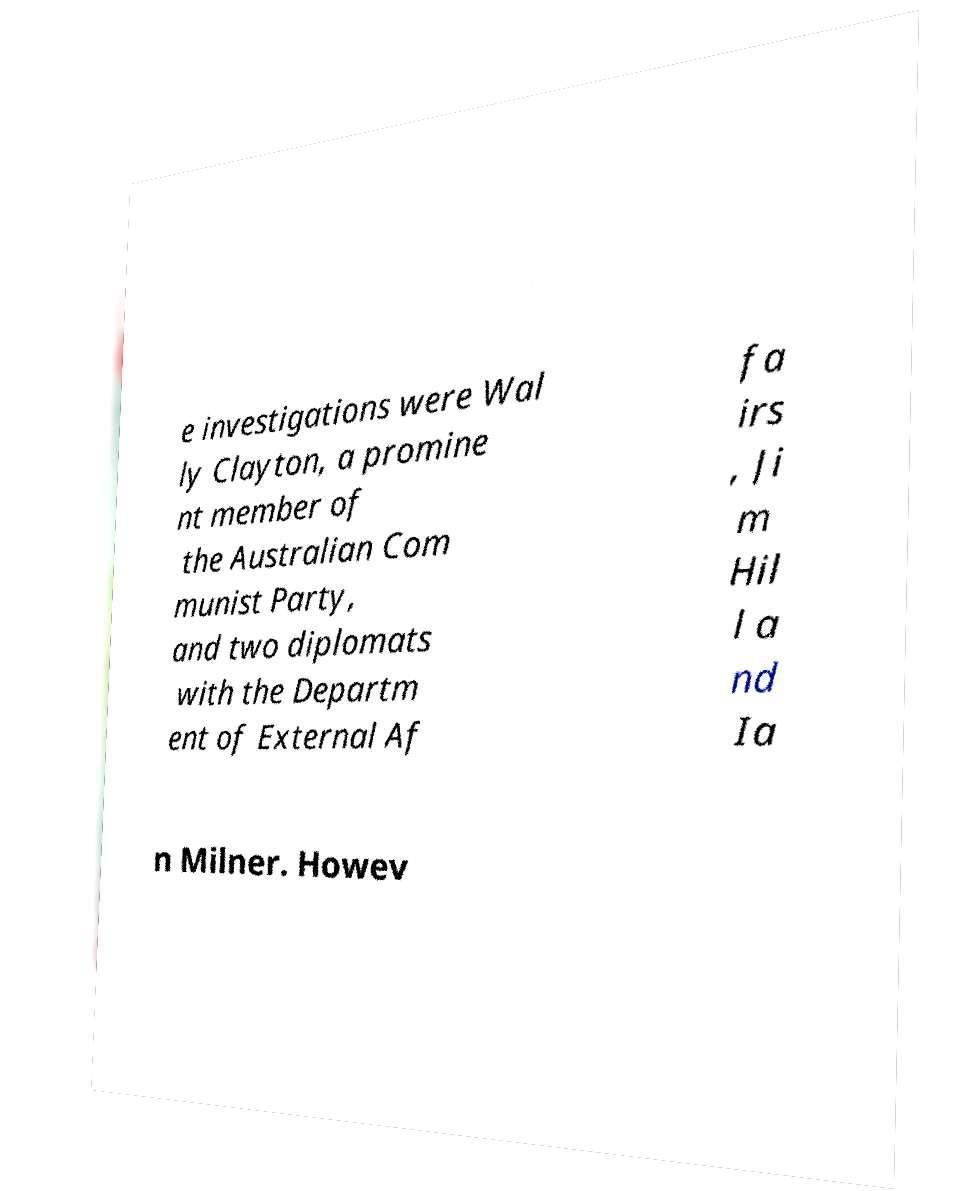Please read and relay the text visible in this image. What does it say? e investigations were Wal ly Clayton, a promine nt member of the Australian Com munist Party, and two diplomats with the Departm ent of External Af fa irs , Ji m Hil l a nd Ia n Milner. Howev 